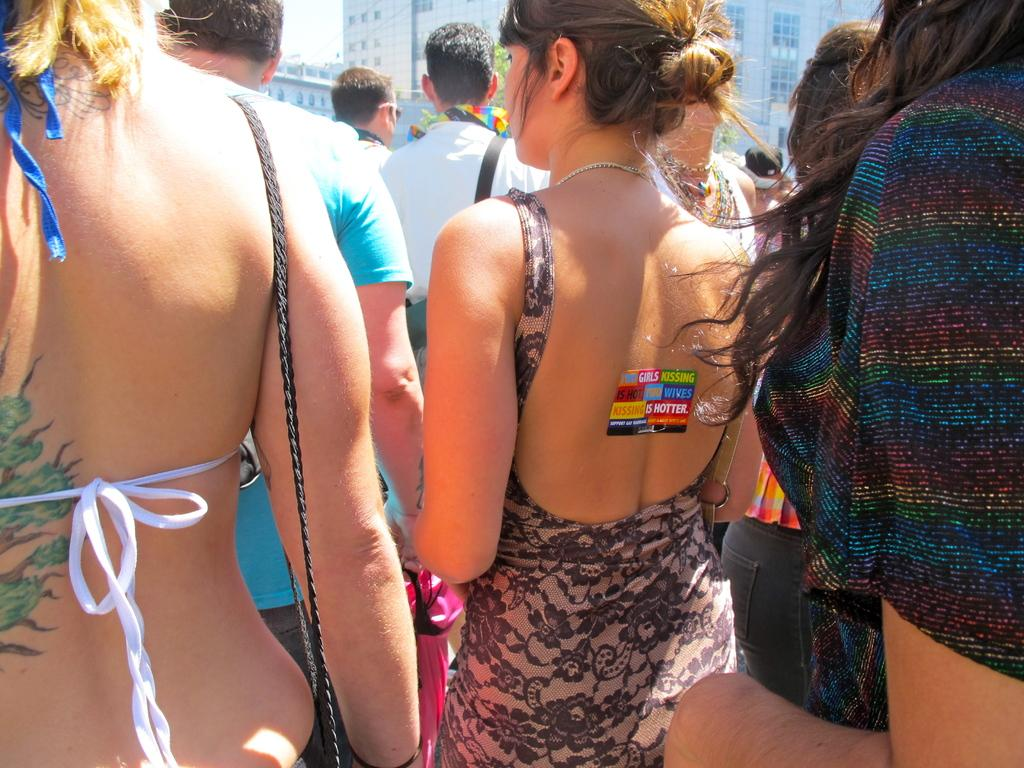What is happening in the image? There are people standing in the image. What natural element can be seen in the image? There is a tree visible in the image. What can be seen in the distance in the image? There are buildings in the background of the image. What type of match is being played in the image? There is no match being played in the image; it only shows people standing and a tree with buildings in the background. 